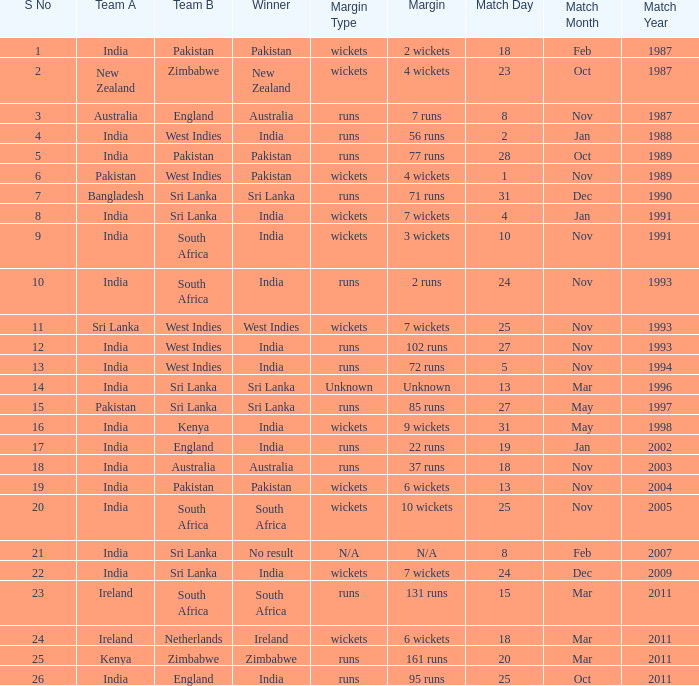What was the margin of the match on 19 Jan 2002? 22 runs. 